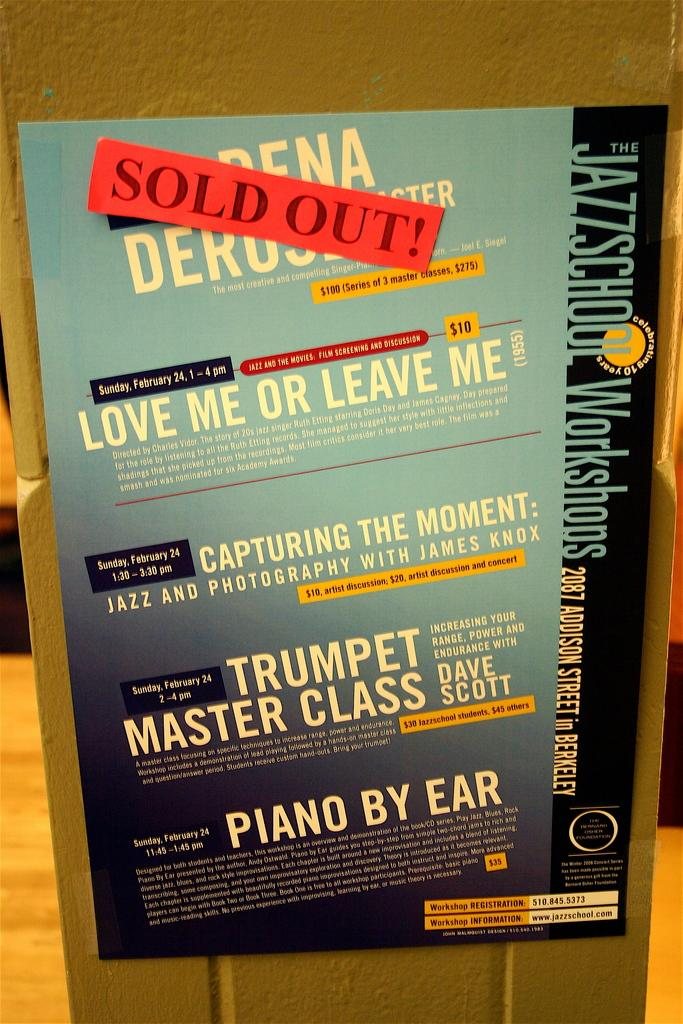<image>
Render a clear and concise summary of the photo. Poster on the wall that says "Love Me or Leave Me". 